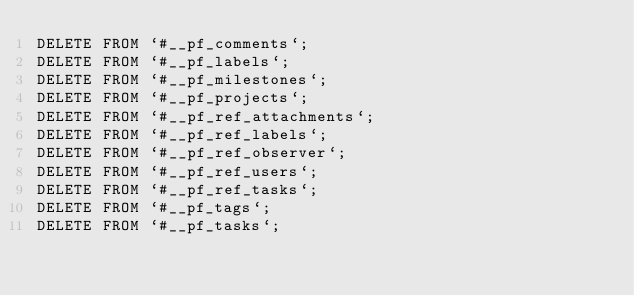Convert code to text. <code><loc_0><loc_0><loc_500><loc_500><_SQL_>DELETE FROM `#__pf_comments`;
DELETE FROM `#__pf_labels`;
DELETE FROM `#__pf_milestones`;
DELETE FROM `#__pf_projects`;
DELETE FROM `#__pf_ref_attachments`;
DELETE FROM `#__pf_ref_labels`;
DELETE FROM `#__pf_ref_observer`;
DELETE FROM `#__pf_ref_users`;
DELETE FROM `#__pf_ref_tasks`;
DELETE FROM `#__pf_tags`;
DELETE FROM `#__pf_tasks`;</code> 